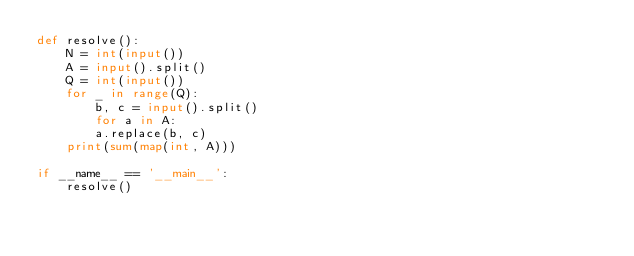<code> <loc_0><loc_0><loc_500><loc_500><_Python_>def resolve():
    N = int(input())
    A = input().split()
    Q = int(input())
    for _ in range(Q):
        b, c = input().split()
        for a in A:
        a.replace(b, c)
    print(sum(map(int, A)))

if __name__ == '__main__':
    resolve()</code> 